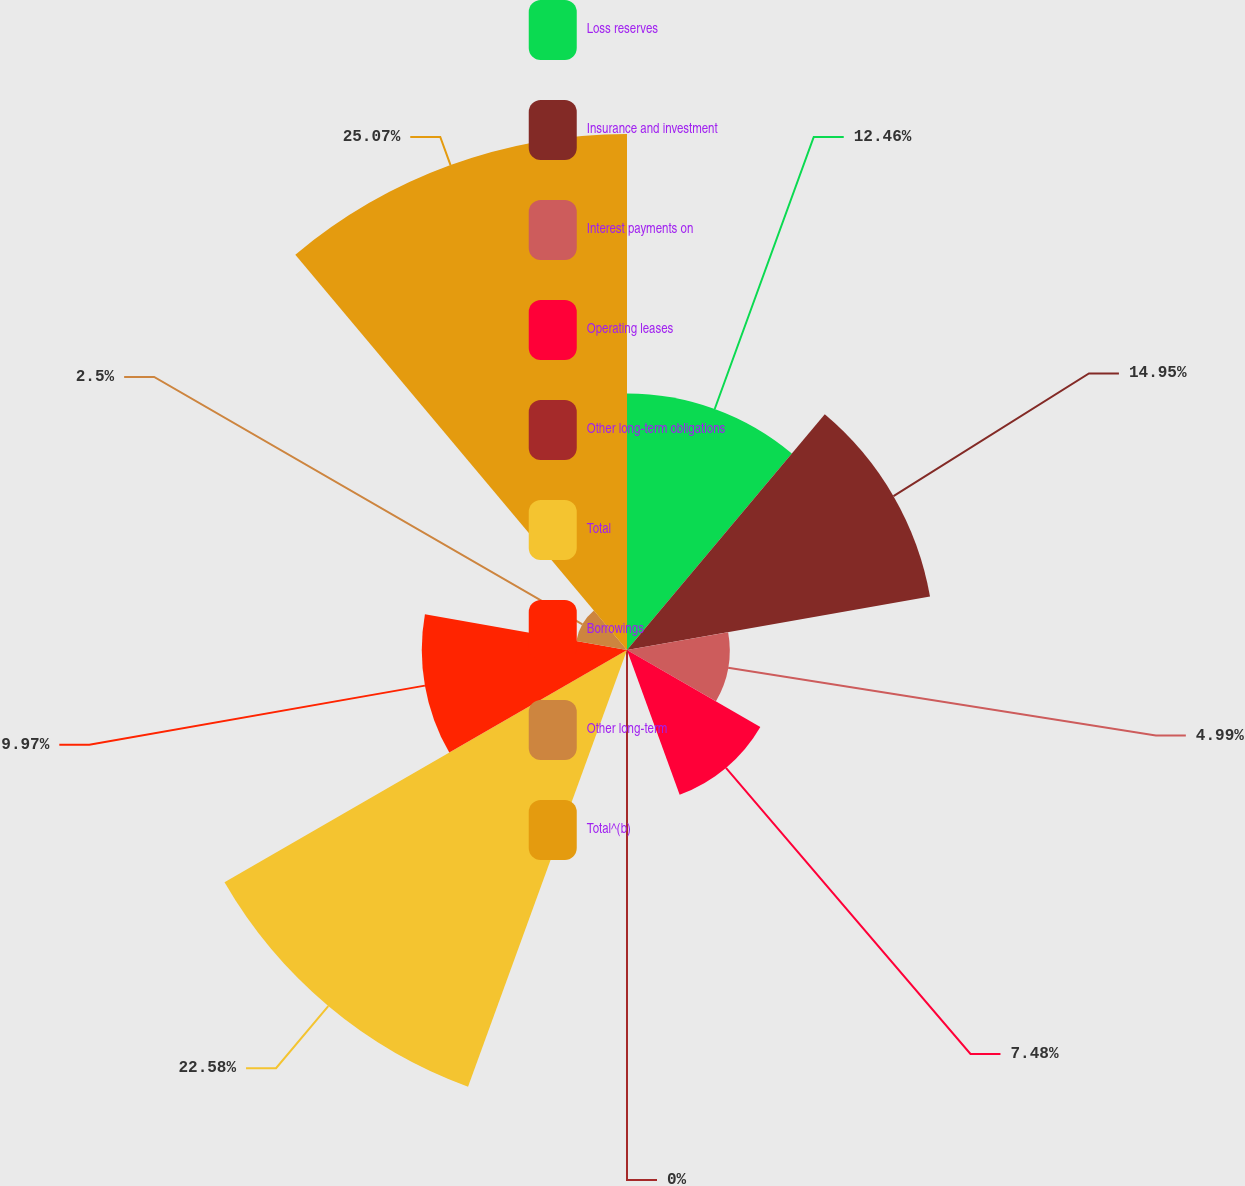Convert chart. <chart><loc_0><loc_0><loc_500><loc_500><pie_chart><fcel>Loss reserves<fcel>Insurance and investment<fcel>Interest payments on<fcel>Operating leases<fcel>Other long-term obligations<fcel>Total<fcel>Borrowings<fcel>Other long-term<fcel>Total^(b)<nl><fcel>12.46%<fcel>14.95%<fcel>4.99%<fcel>7.48%<fcel>0.0%<fcel>22.58%<fcel>9.97%<fcel>2.5%<fcel>25.07%<nl></chart> 